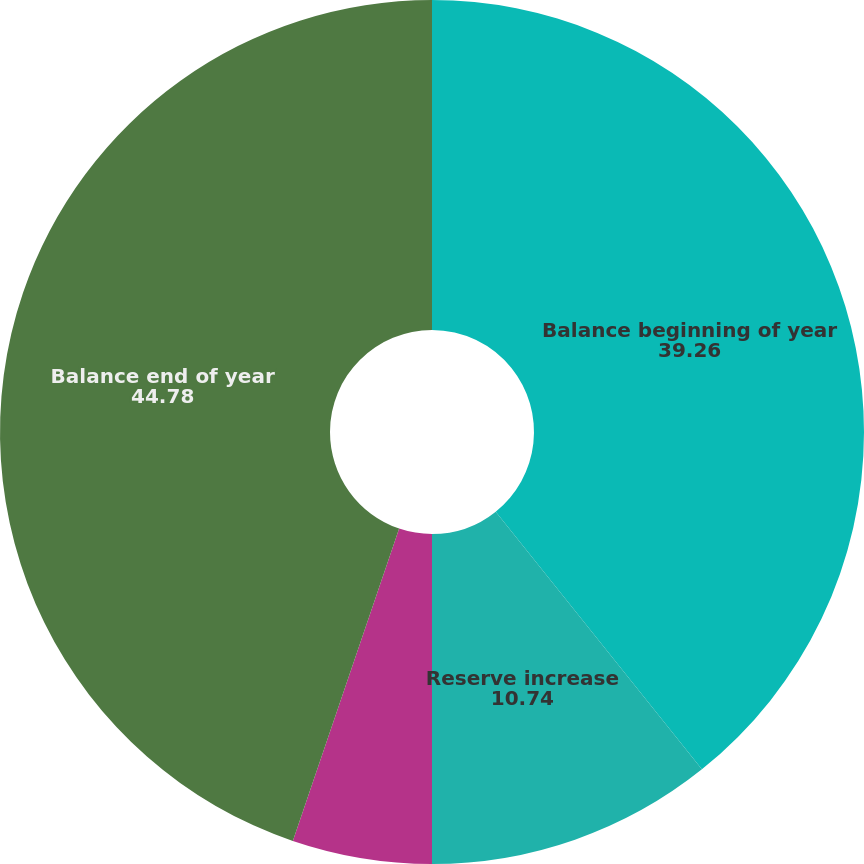<chart> <loc_0><loc_0><loc_500><loc_500><pie_chart><fcel>Balance beginning of year<fcel>Reserve increase<fcel>Benefits paid<fcel>Balance end of year<nl><fcel>39.26%<fcel>10.74%<fcel>5.22%<fcel>44.78%<nl></chart> 